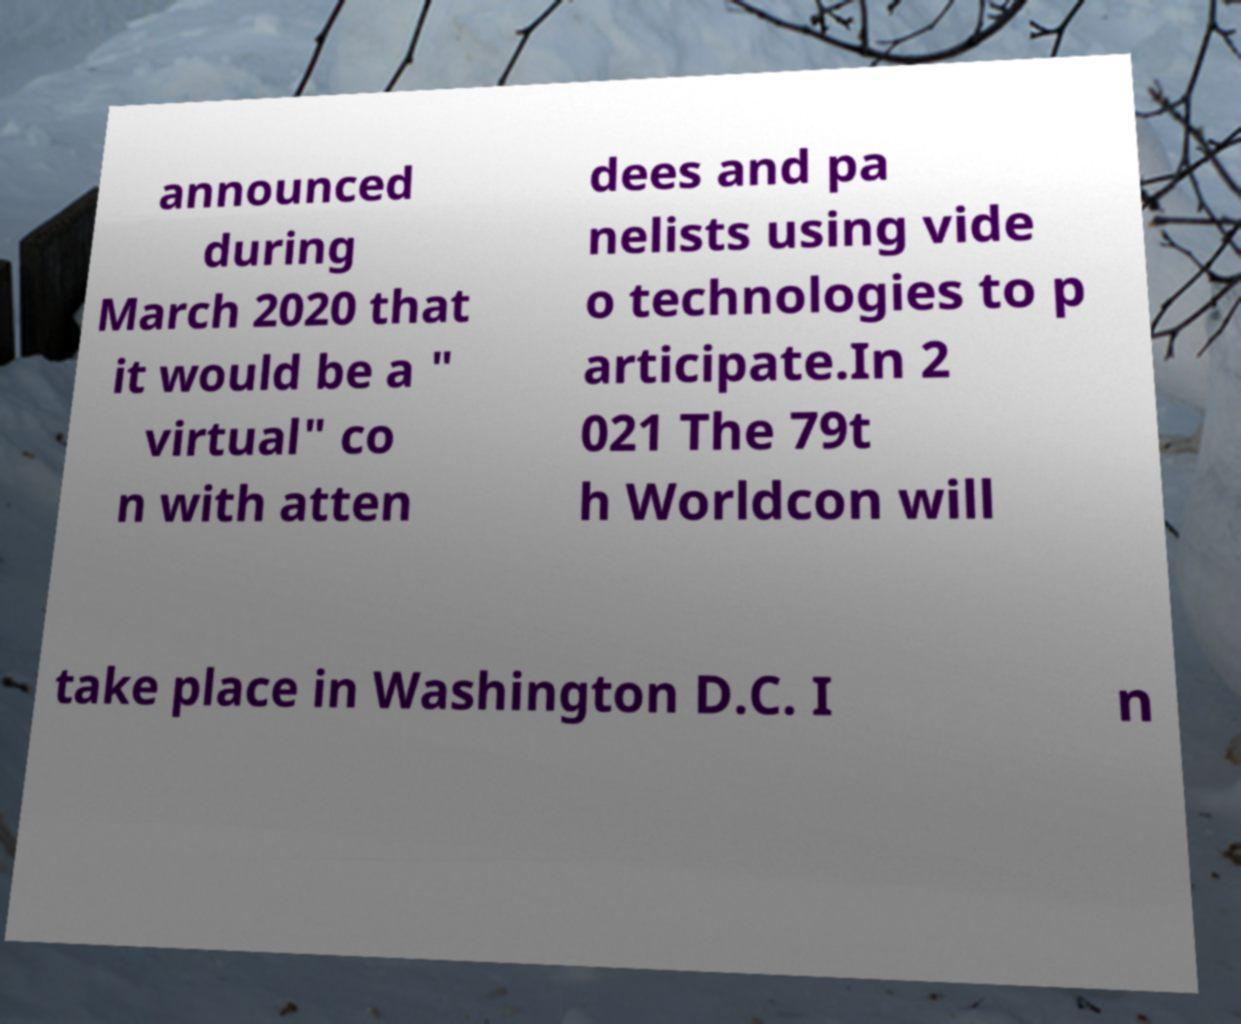Can you read and provide the text displayed in the image?This photo seems to have some interesting text. Can you extract and type it out for me? announced during March 2020 that it would be a " virtual" co n with atten dees and pa nelists using vide o technologies to p articipate.In 2 021 The 79t h Worldcon will take place in Washington D.C. I n 